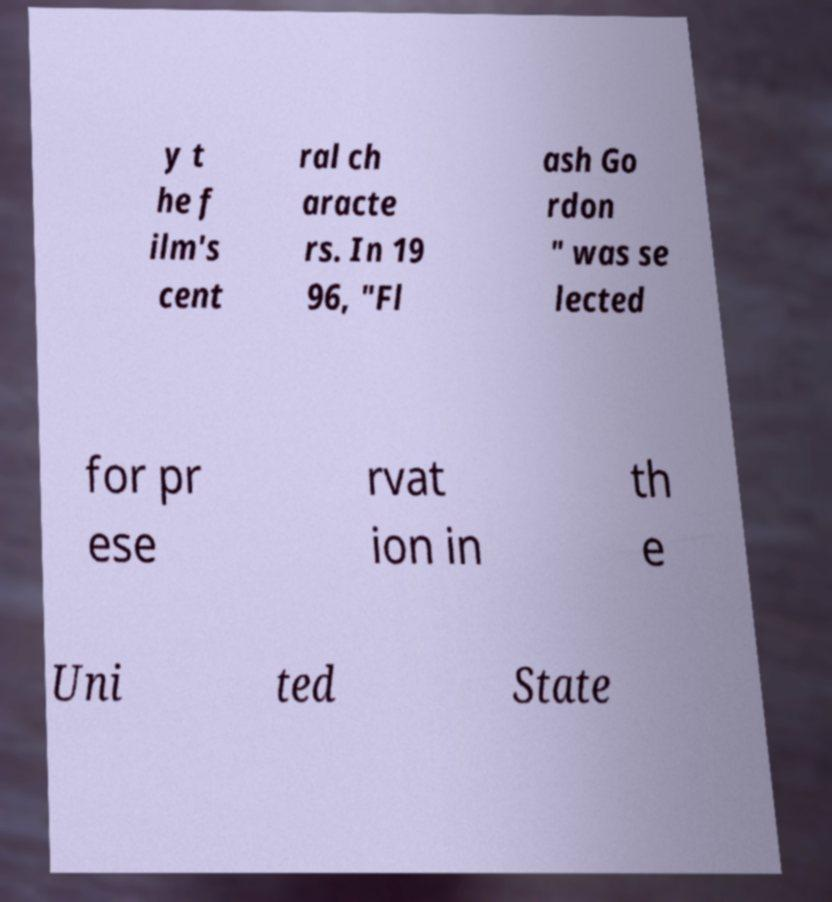Can you accurately transcribe the text from the provided image for me? y t he f ilm's cent ral ch aracte rs. In 19 96, "Fl ash Go rdon " was se lected for pr ese rvat ion in th e Uni ted State 